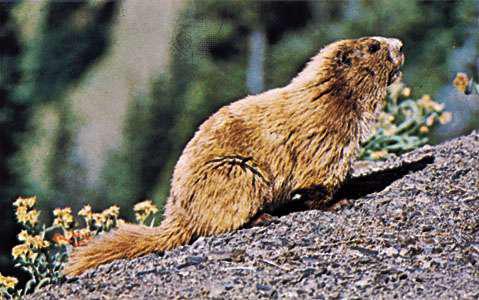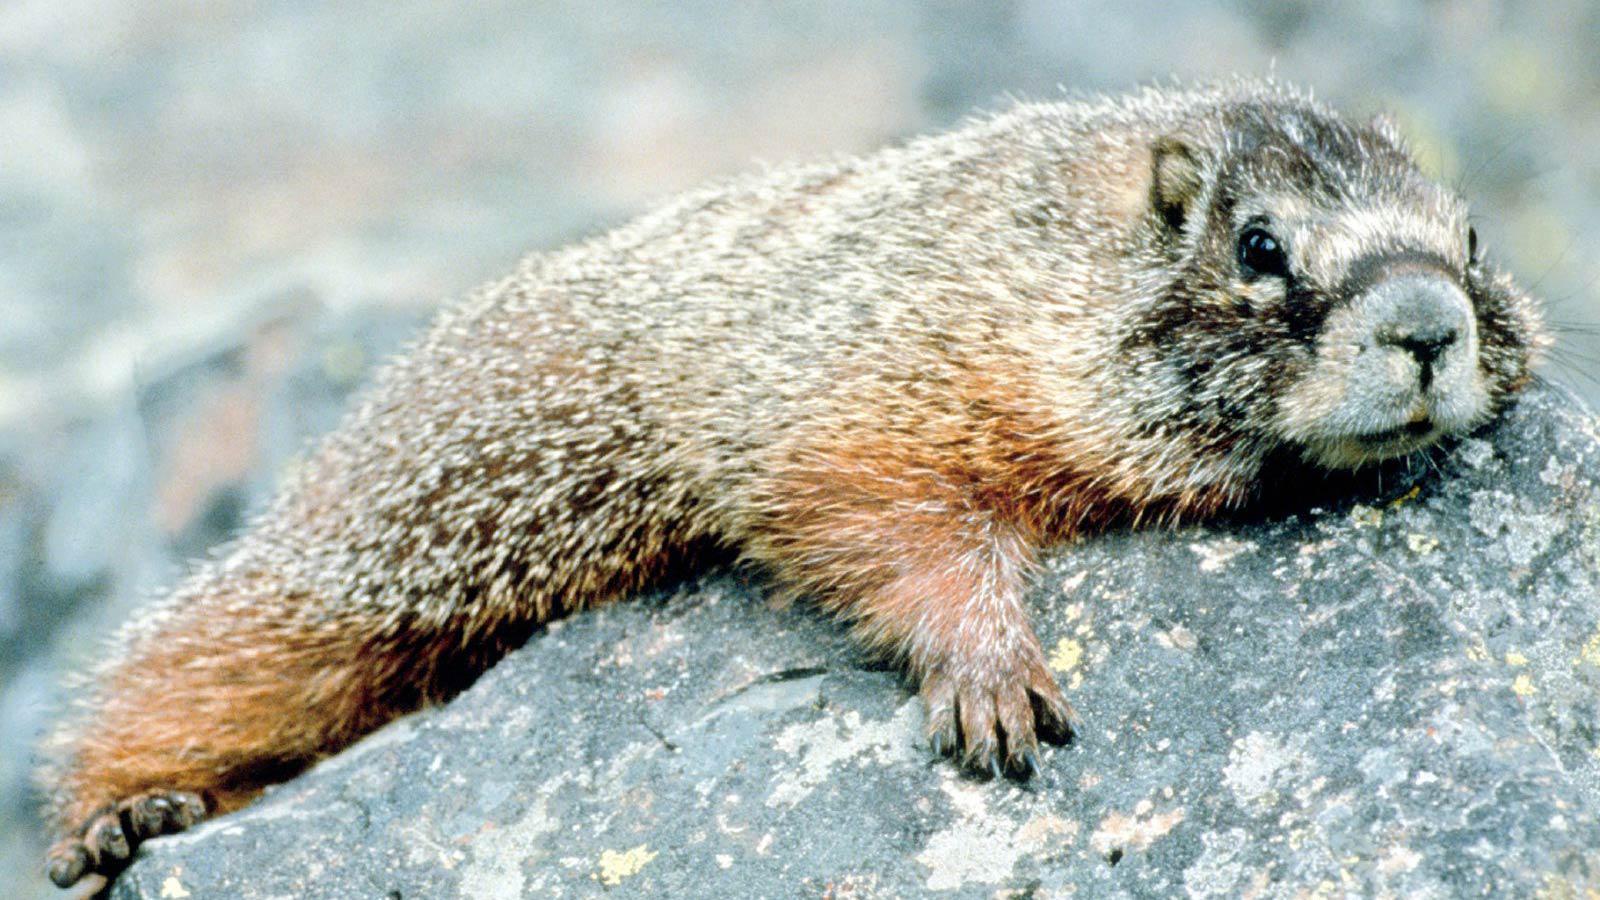The first image is the image on the left, the second image is the image on the right. Evaluate the accuracy of this statement regarding the images: "One image includes multiple marmots that are standing on their hind legs and have their front paws raised.". Is it true? Answer yes or no. No. The first image is the image on the left, the second image is the image on the right. Considering the images on both sides, is "There are two marmots total." valid? Answer yes or no. Yes. 